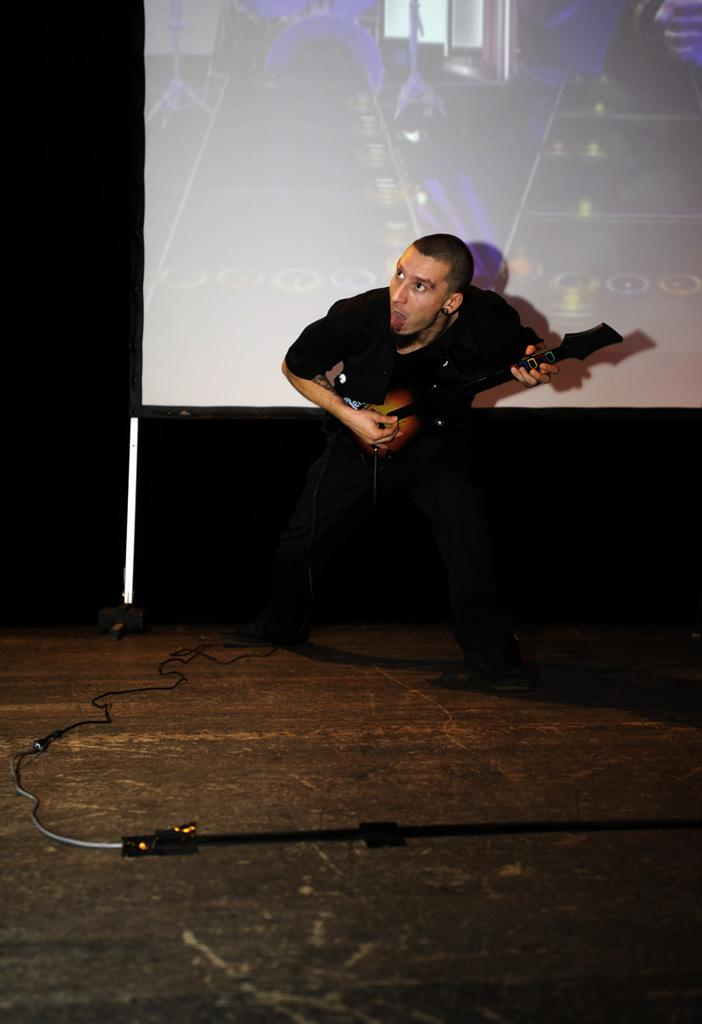What is the main subject of the image? There is a man in the image. What is the man wearing? The man is wearing a black shirt and black jeans. What is the man holding in his hand? The man is holding a guitar in his hand. What can be seen in the background of the image? There is a screen visible in the background of the image. What else can be seen in the image besides the man and the screen? There is a wire visible in the image. What type of design can be seen on the man's toe in the image? There is no information about the man's toe or any design on it in the image. 